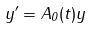<formula> <loc_0><loc_0><loc_500><loc_500>y ^ { \prime } = A _ { 0 } ( t ) y</formula> 